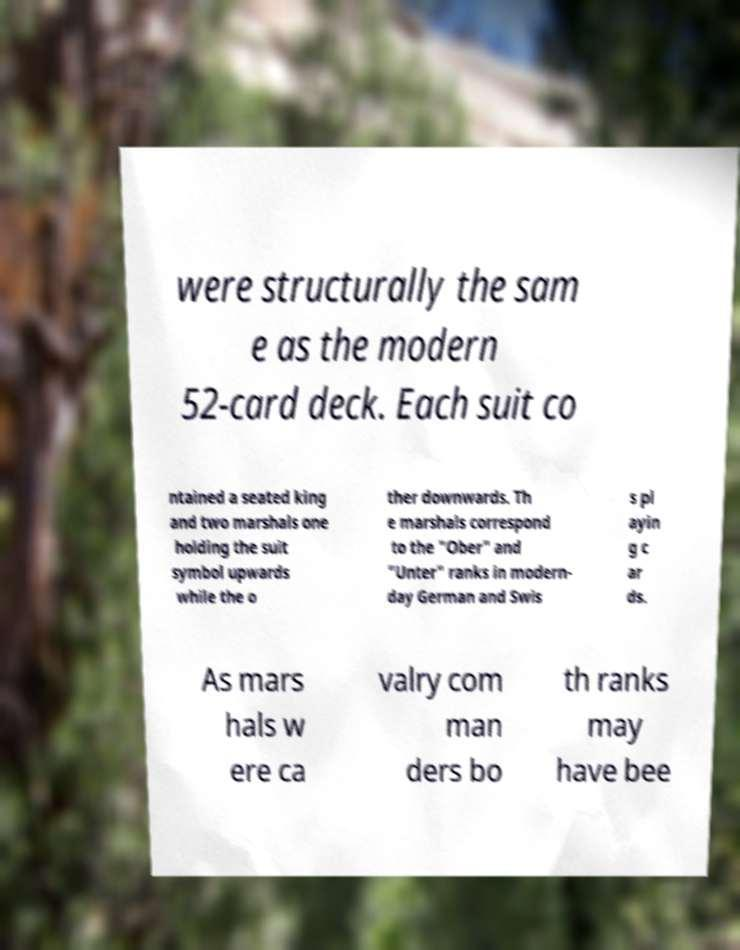Please identify and transcribe the text found in this image. were structurally the sam e as the modern 52-card deck. Each suit co ntained a seated king and two marshals one holding the suit symbol upwards while the o ther downwards. Th e marshals correspond to the "Ober" and "Unter" ranks in modern- day German and Swis s pl ayin g c ar ds. As mars hals w ere ca valry com man ders bo th ranks may have bee 